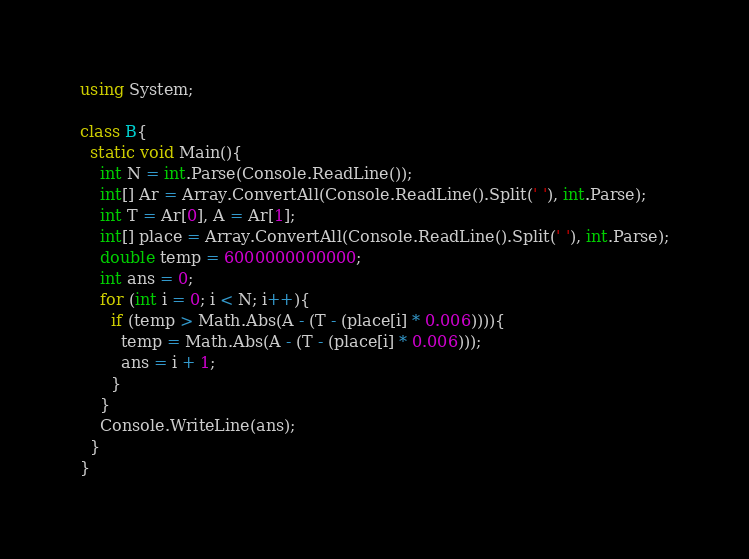Convert code to text. <code><loc_0><loc_0><loc_500><loc_500><_C#_>using System;

class B{
  static void Main(){
    int N = int.Parse(Console.ReadLine());
    int[] Ar = Array.ConvertAll(Console.ReadLine().Split(' '), int.Parse);
    int T = Ar[0], A = Ar[1];
    int[] place = Array.ConvertAll(Console.ReadLine().Split(' '), int.Parse);
    double temp = 6000000000000;
    int ans = 0;
    for (int i = 0; i < N; i++){
      if (temp > Math.Abs(A - (T - (place[i] * 0.006)))){
        temp = Math.Abs(A - (T - (place[i] * 0.006)));
        ans = i + 1;
      }
    }
    Console.WriteLine(ans);
  }
}</code> 